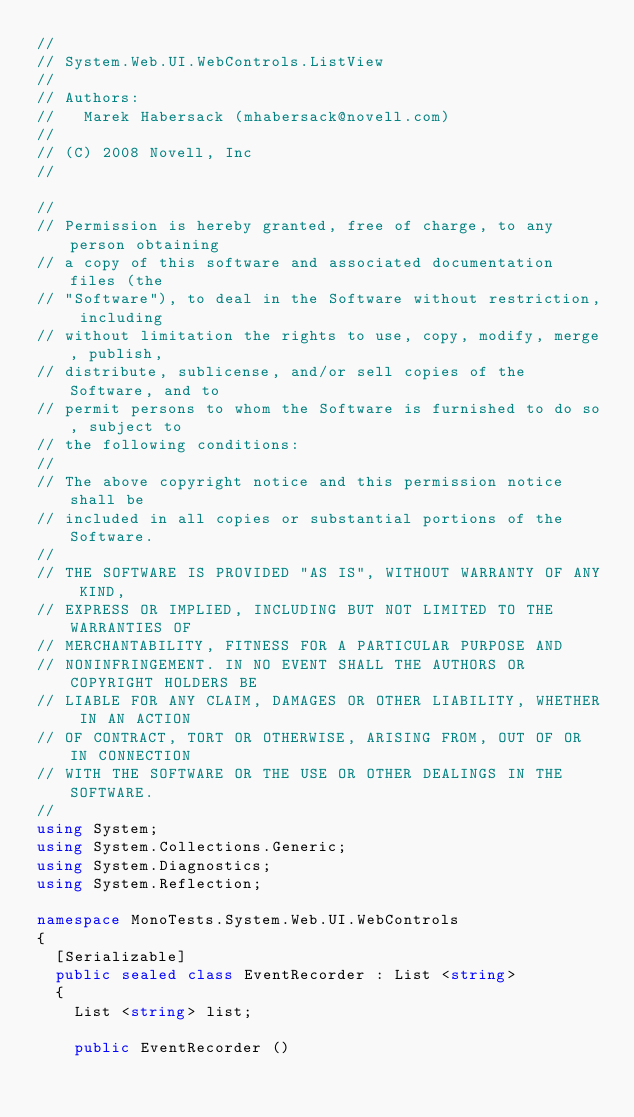Convert code to text. <code><loc_0><loc_0><loc_500><loc_500><_C#_>//
// System.Web.UI.WebControls.ListView
//
// Authors:
//   Marek Habersack (mhabersack@novell.com)
//
// (C) 2008 Novell, Inc
//

//
// Permission is hereby granted, free of charge, to any person obtaining
// a copy of this software and associated documentation files (the
// "Software"), to deal in the Software without restriction, including
// without limitation the rights to use, copy, modify, merge, publish,
// distribute, sublicense, and/or sell copies of the Software, and to
// permit persons to whom the Software is furnished to do so, subject to
// the following conditions:
// 
// The above copyright notice and this permission notice shall be
// included in all copies or substantial portions of the Software.
// 
// THE SOFTWARE IS PROVIDED "AS IS", WITHOUT WARRANTY OF ANY KIND,
// EXPRESS OR IMPLIED, INCLUDING BUT NOT LIMITED TO THE WARRANTIES OF
// MERCHANTABILITY, FITNESS FOR A PARTICULAR PURPOSE AND
// NONINFRINGEMENT. IN NO EVENT SHALL THE AUTHORS OR COPYRIGHT HOLDERS BE
// LIABLE FOR ANY CLAIM, DAMAGES OR OTHER LIABILITY, WHETHER IN AN ACTION
// OF CONTRACT, TORT OR OTHERWISE, ARISING FROM, OUT OF OR IN CONNECTION
// WITH THE SOFTWARE OR THE USE OR OTHER DEALINGS IN THE SOFTWARE.
//
using System;
using System.Collections.Generic;
using System.Diagnostics;
using System.Reflection;

namespace MonoTests.System.Web.UI.WebControls
{
	[Serializable]
	public sealed class EventRecorder : List <string>
	{
		List <string> list;

		public EventRecorder ()</code> 